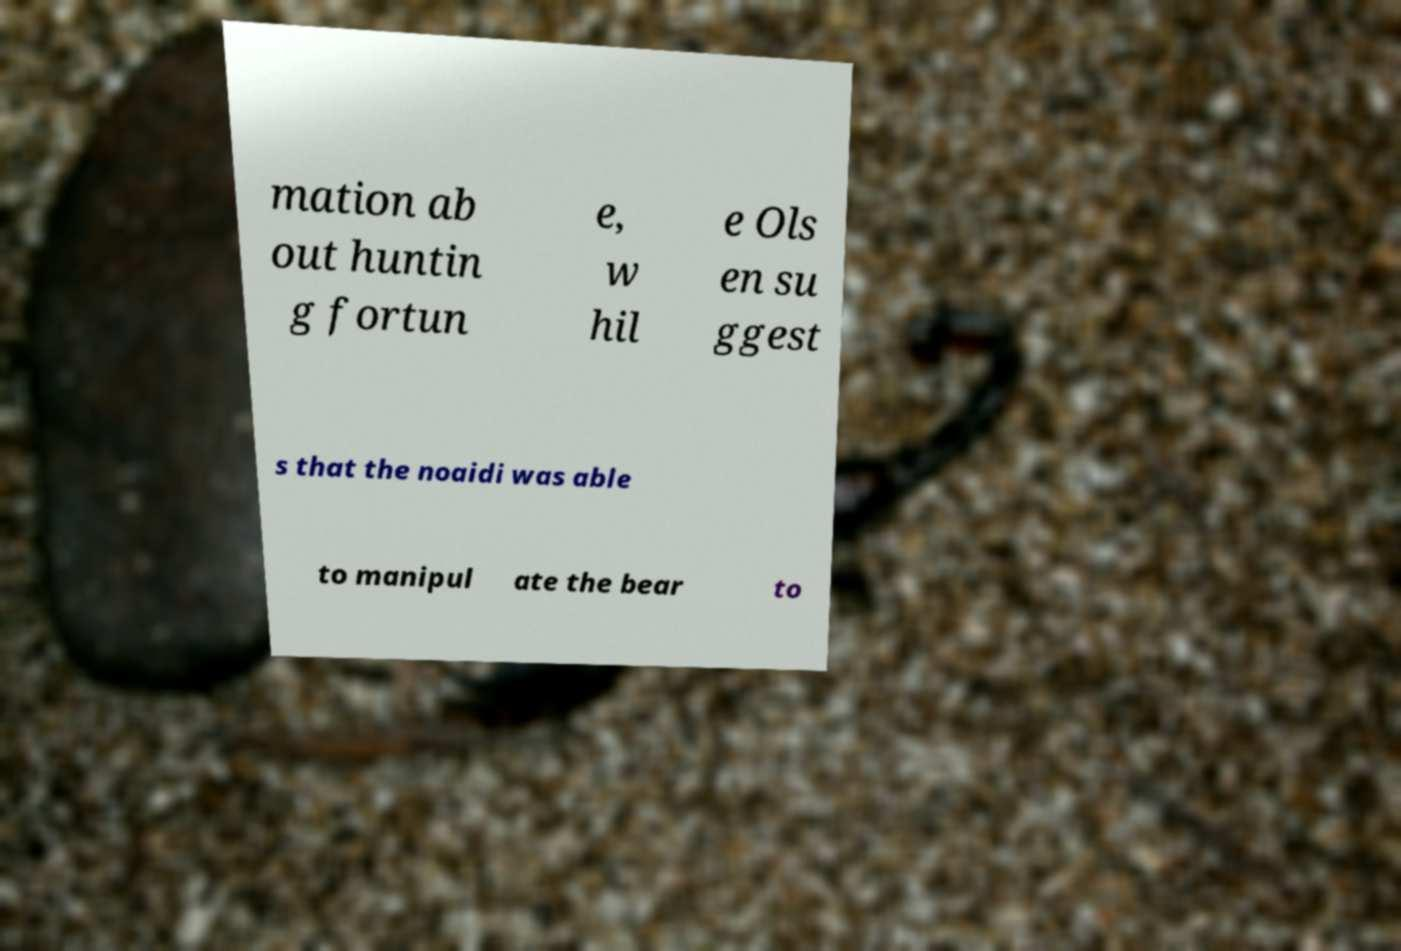Could you extract and type out the text from this image? mation ab out huntin g fortun e, w hil e Ols en su ggest s that the noaidi was able to manipul ate the bear to 